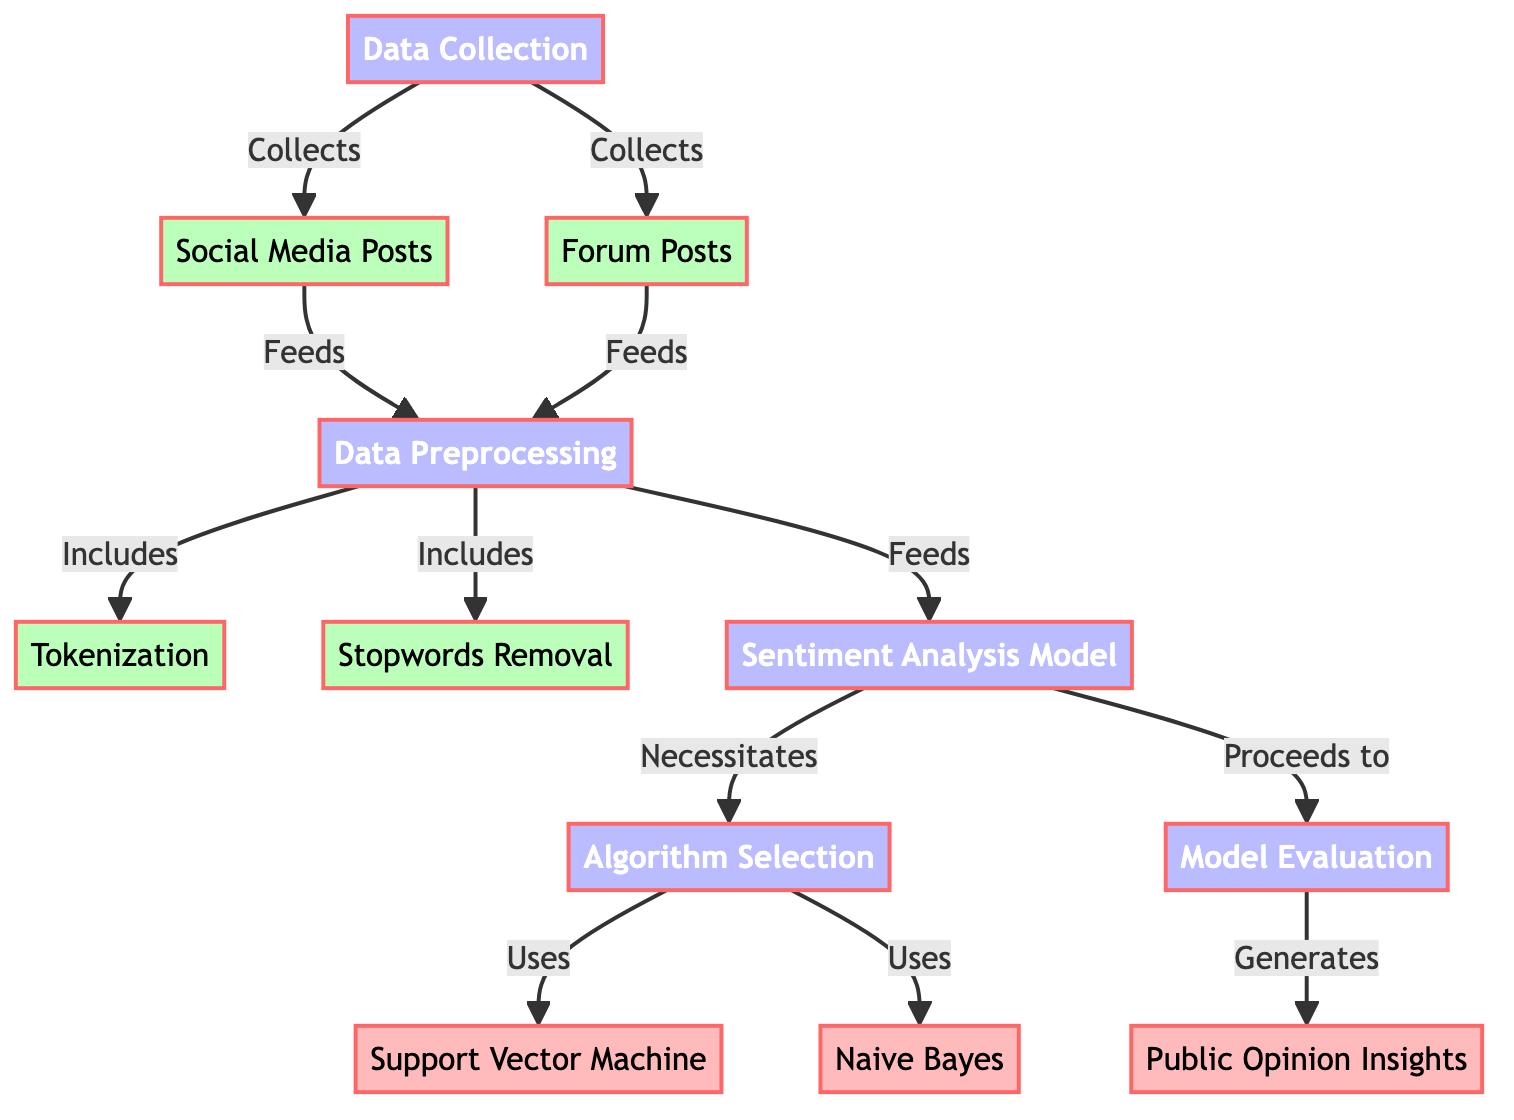What are the two sources of data collection? The diagram shows that the data collection node collects data from two sources: social media posts and forum posts.
Answer: social media posts, forum posts What process occurs after data preprocessing? After the data preprocessing step, which includes tokenization and stopwords removal, the next step is sentiment analysis.
Answer: sentiment analysis How many algorithms are selected in the algorithm selection step? The algorithm selection node indicates the use of two algorithms: Support Vector Machine and Naive Bayes. Therefore, there are two algorithms involved in this step.
Answer: two What are the final outputs generated in the evaluation stage? The evaluation stage generates public opinion insights based on the processed data. This is indicated as the final outcome of the diagram's flow.
Answer: public opinion insights Which process includes tokenization? The tokenization process is included as part of data preprocessing, which serves as a critical step in preparing the collected data for sentiment analysis.
Answer: data preprocessing What does the sentiment analysis model necessitate? The sentiment analysis model necessitates the algorithm selection step, implying that choosing an appropriate algorithm is essential for the sentiment analysis process to proceed.
Answer: algorithm selection Which algorithm is part of the chosen algorithms for sentiment analysis? The diagram shows that both Support Vector Machine and Naive Bayes are part of the selected algorithms for the sentiment analysis model during the algorithm selection phase.
Answer: Support Vector Machine, Naive Bayes What type of data is removed in the stopwords removal process? The stopwords removal process is specifically aimed at filtering out common words that do not contribute meaningfully to the analysis, thus enhancing the quality of the data for sentiment analysis.
Answer: common words 